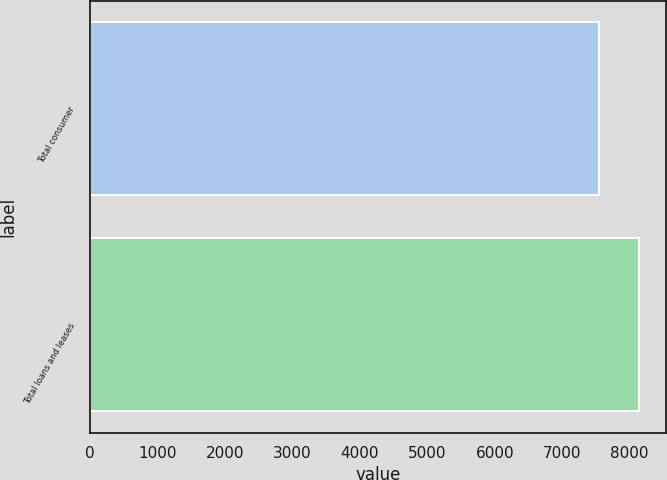Convert chart to OTSL. <chart><loc_0><loc_0><loc_500><loc_500><bar_chart><fcel>Total consumer<fcel>Total loans and leases<nl><fcel>7545<fcel>8134<nl></chart> 